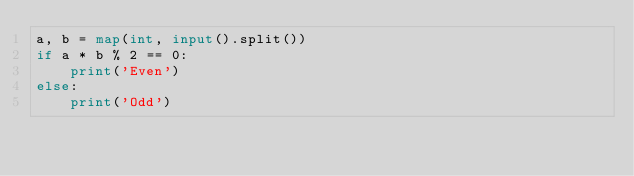Convert code to text. <code><loc_0><loc_0><loc_500><loc_500><_Python_>a, b = map(int, input().split())
if a * b % 2 == 0:
    print('Even')
else:
    print('Odd')
</code> 